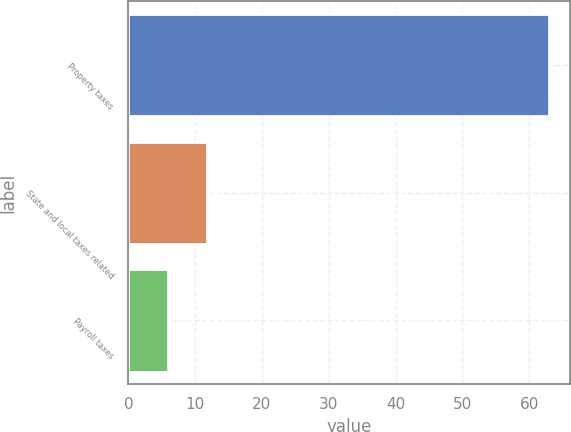<chart> <loc_0><loc_0><loc_500><loc_500><bar_chart><fcel>Property taxes<fcel>State and local taxes related<fcel>Payroll taxes<nl><fcel>63<fcel>11.7<fcel>6<nl></chart> 